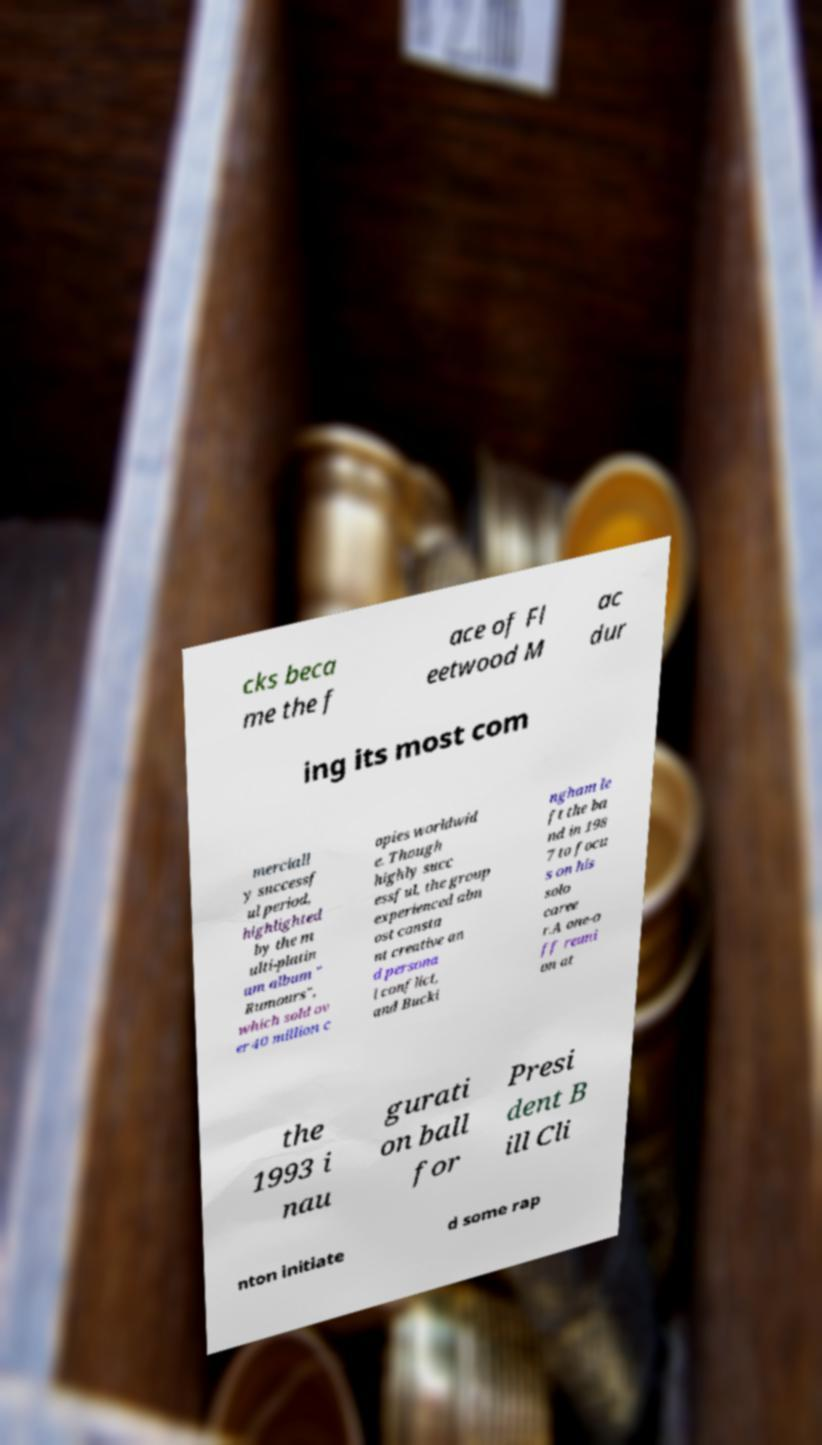For documentation purposes, I need the text within this image transcribed. Could you provide that? cks beca me the f ace of Fl eetwood M ac dur ing its most com merciall y successf ul period, highlighted by the m ulti-platin um album " Rumours", which sold ov er 40 million c opies worldwid e. Though highly succ essful, the group experienced alm ost consta nt creative an d persona l conflict, and Bucki ngham le ft the ba nd in 198 7 to focu s on his solo caree r.A one-o ff reuni on at the 1993 i nau gurati on ball for Presi dent B ill Cli nton initiate d some rap 